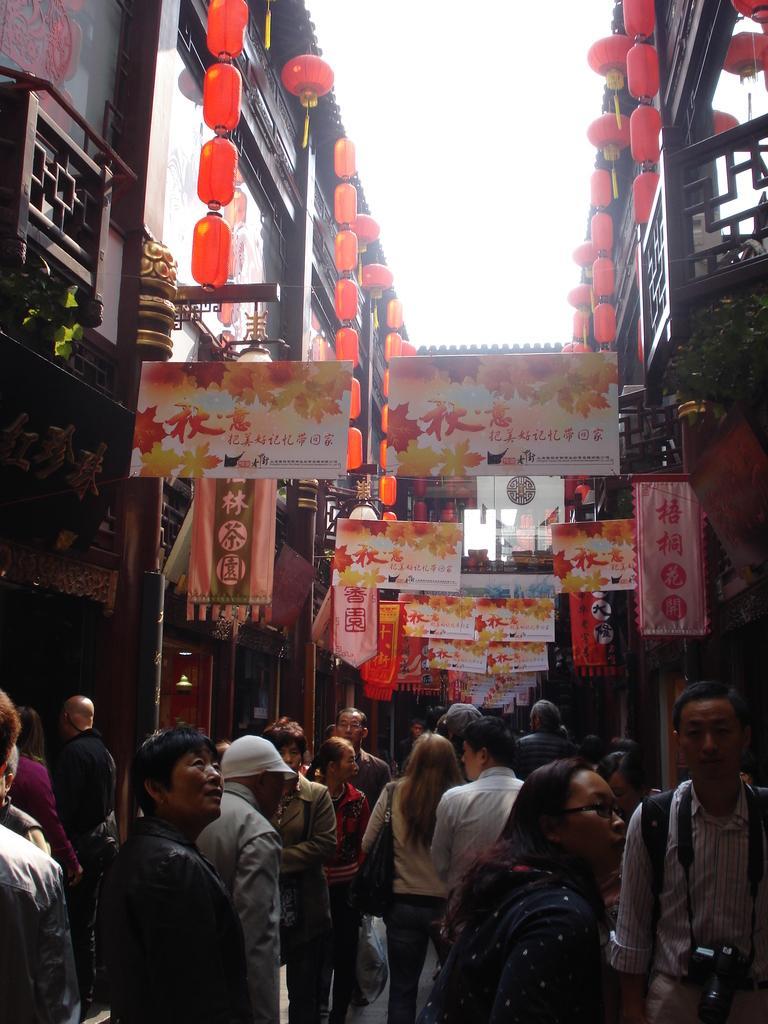In one or two sentences, can you explain what this image depicts? In the center of the image we can see the buildings, balcony, plants, pots, boards, lights, wall. At the bottom of the image we can see a group of people are standing on the road. At the top of the image we can see the sky. 